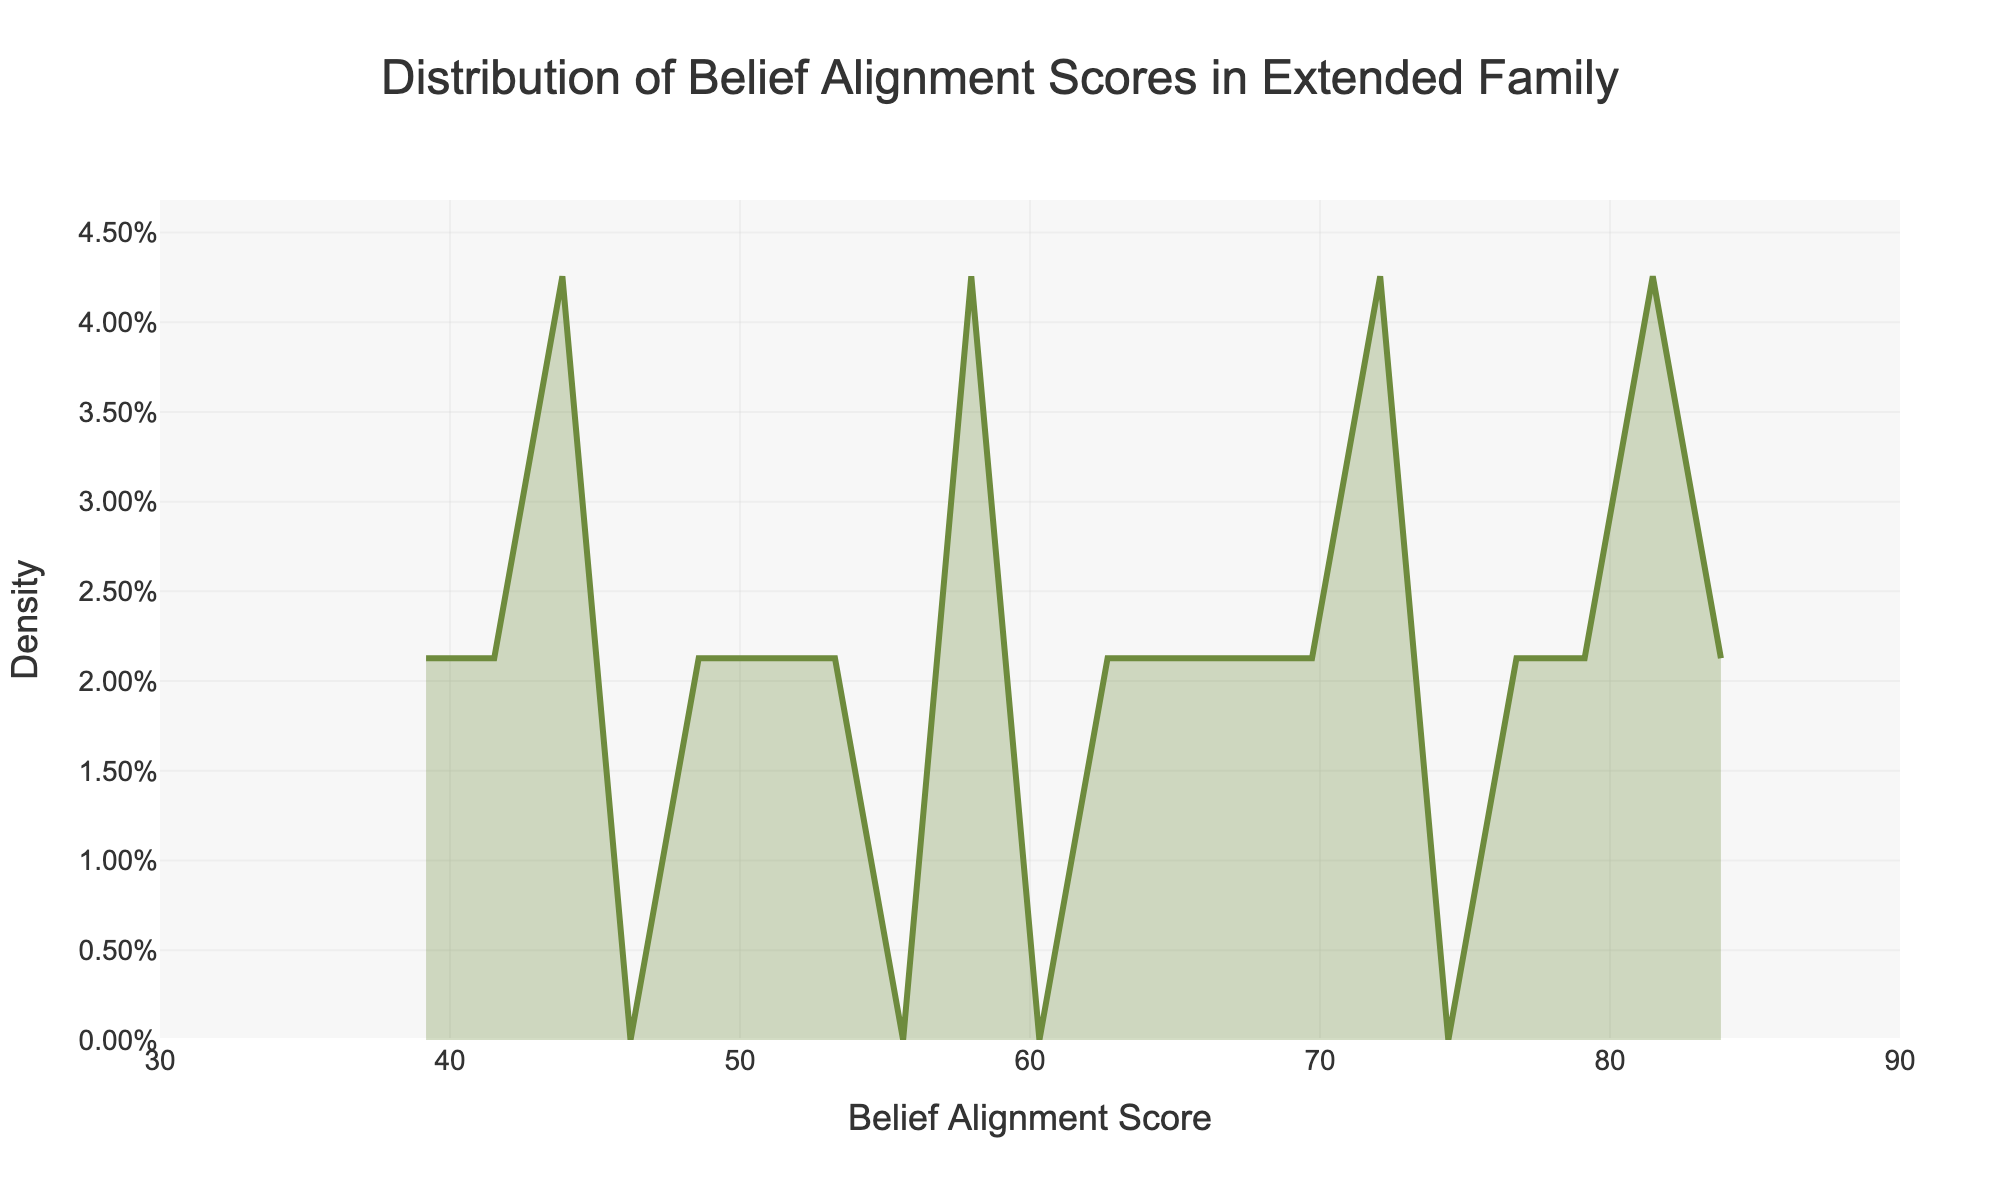What is the title of the plot? The title of the plot is displayed prominently at the top. It helps to understand the context of the data presented.
Answer: Distribution of Belief Alignment Scores in Extended Family What is the range of Belief Alignment Scores shown on the x-axis? The x-axis of the plot shows the range of Belief Alignment Scores, starting from the leftmost tick mark to the rightmost one.
Answer: 30 to 90 How are the belief alignment scores distributed in the family? By looking at the curve on the density plot, you can see how the scores are spread out across the x-axis. The density shows where the scores cluster.
Answer: The scores are more clustered in the middle range around 50 to 70 What color is used to fill the area under the density curve? The area under the density curve is filled with a specific color, which visually helps in identifying the data distribution.
Answer: A light olive green (rgba(110, 139, 61, 0.3)) What does the y-axis represent? The y-axis indicates what is being measured by the density curve, which helps in understanding the distribution of the data.
Answer: Density What belief alignment score range has the highest density? By observing the peak of the density curve, you can determine the range of scores where the density is highest.
Answer: Around 60 to 70 Is there any clear outlier in the Belief Alignment Scores distribution? Observing the density curve and checking for any isolated peaks or troughs can indicate the presence of outliers.
Answer: No clear outliers are present How do the belief alignment scores of Grandma and Grandpa compare? Compare the specific belief alignment scores of Grandma (85) and Grandpa (82) to see which one is higher or if they are similar.
Answer: Grandma has a slightly higher score (85) compared to Grandpa (82) Which family member has a belief alignment score closest to the peak density? Identify the family member whose score is nearest to the highest peak of the density curve, indicating where most family members' belief alignments are grouped.
Answer: Uncle Steve with a score of 70 Considering the distribution, would you say the family's belief alignment is more similar or diverse? By evaluating the overall shape and spread of the density curve, you can interpret how varied or uniform the belief alignment is within the family.
Answer: More similar, as most scores fall within a narrow middle range 